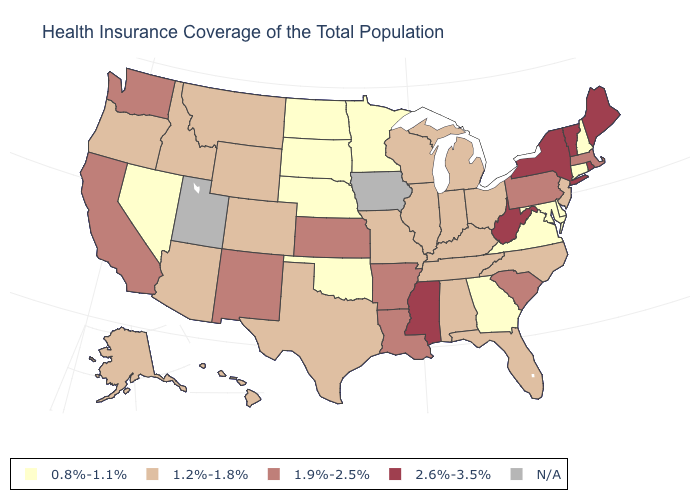Which states hav the highest value in the West?
Answer briefly. California, New Mexico, Washington. What is the value of Vermont?
Answer briefly. 2.6%-3.5%. Name the states that have a value in the range 0.8%-1.1%?
Concise answer only. Connecticut, Delaware, Georgia, Maryland, Minnesota, Nebraska, Nevada, New Hampshire, North Dakota, Oklahoma, South Dakota, Virginia. Name the states that have a value in the range 2.6%-3.5%?
Short answer required. Maine, Mississippi, New York, Rhode Island, Vermont, West Virginia. Among the states that border Montana , does South Dakota have the lowest value?
Be succinct. Yes. Which states have the lowest value in the South?
Write a very short answer. Delaware, Georgia, Maryland, Oklahoma, Virginia. Which states have the highest value in the USA?
Keep it brief. Maine, Mississippi, New York, Rhode Island, Vermont, West Virginia. Is the legend a continuous bar?
Quick response, please. No. Among the states that border Connecticut , which have the lowest value?
Short answer required. Massachusetts. Name the states that have a value in the range 1.2%-1.8%?
Write a very short answer. Alabama, Alaska, Arizona, Colorado, Florida, Hawaii, Idaho, Illinois, Indiana, Kentucky, Michigan, Missouri, Montana, New Jersey, North Carolina, Ohio, Oregon, Tennessee, Texas, Wisconsin, Wyoming. What is the value of Tennessee?
Short answer required. 1.2%-1.8%. Does the first symbol in the legend represent the smallest category?
Write a very short answer. Yes. Does Illinois have the lowest value in the USA?
Be succinct. No. 